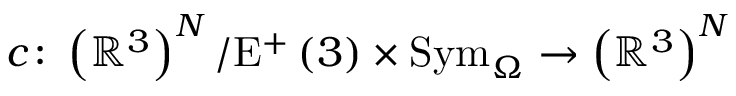<formula> <loc_0><loc_0><loc_500><loc_500>c \colon \left ( \mathbb { R } ^ { 3 } \right ) ^ { N } / E ^ { + } \left ( 3 \right ) \times S y m _ { \Omega } \rightarrow \left ( \mathbb { R } ^ { 3 } \right ) ^ { N }</formula> 